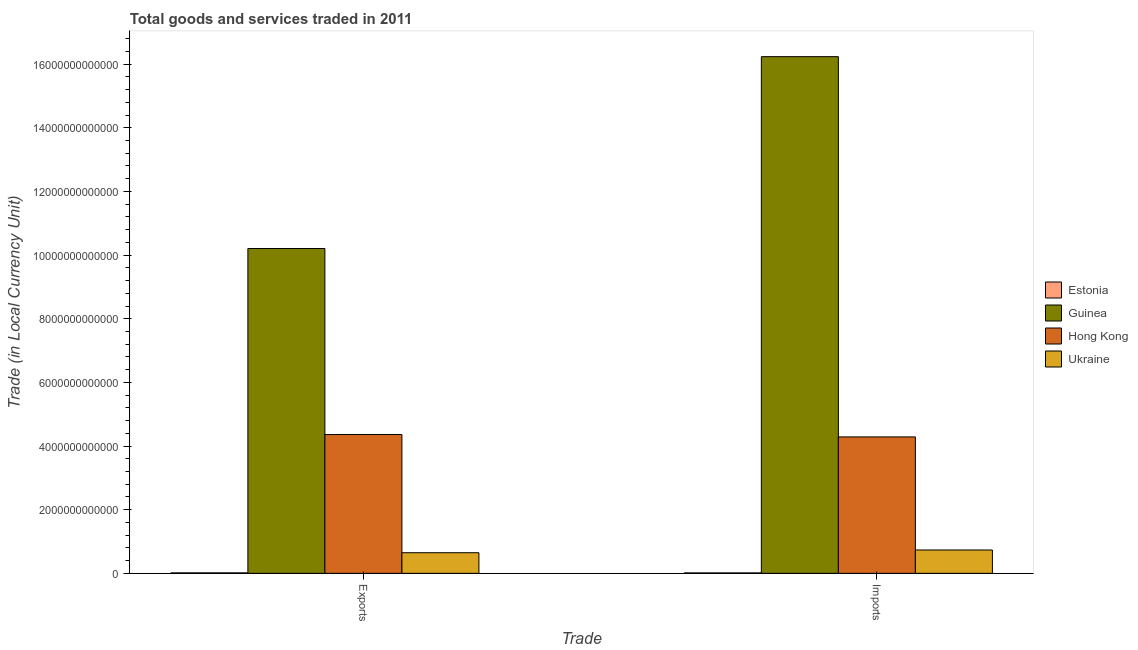Are the number of bars per tick equal to the number of legend labels?
Your answer should be very brief. Yes. Are the number of bars on each tick of the X-axis equal?
Offer a very short reply. Yes. How many bars are there on the 1st tick from the left?
Your response must be concise. 4. How many bars are there on the 1st tick from the right?
Offer a terse response. 4. What is the label of the 2nd group of bars from the left?
Keep it short and to the point. Imports. What is the imports of goods and services in Estonia?
Ensure brevity in your answer.  1.35e+1. Across all countries, what is the maximum imports of goods and services?
Ensure brevity in your answer.  1.62e+13. Across all countries, what is the minimum export of goods and services?
Provide a short and direct response. 1.44e+1. In which country was the export of goods and services maximum?
Your response must be concise. Guinea. In which country was the export of goods and services minimum?
Give a very brief answer. Estonia. What is the total imports of goods and services in the graph?
Make the answer very short. 2.13e+13. What is the difference between the imports of goods and services in Estonia and that in Ukraine?
Make the answer very short. -7.20e+11. What is the difference between the export of goods and services in Estonia and the imports of goods and services in Hong Kong?
Ensure brevity in your answer.  -4.27e+12. What is the average imports of goods and services per country?
Give a very brief answer. 5.32e+12. What is the difference between the export of goods and services and imports of goods and services in Hong Kong?
Keep it short and to the point. 7.45e+1. What is the ratio of the export of goods and services in Guinea to that in Estonia?
Your response must be concise. 707.66. Is the export of goods and services in Guinea less than that in Estonia?
Ensure brevity in your answer.  No. What does the 1st bar from the left in Imports represents?
Make the answer very short. Estonia. What does the 4th bar from the right in Exports represents?
Ensure brevity in your answer.  Estonia. Are all the bars in the graph horizontal?
Your answer should be compact. No. What is the difference between two consecutive major ticks on the Y-axis?
Offer a terse response. 2.00e+12. Does the graph contain any zero values?
Your response must be concise. No. Does the graph contain grids?
Your answer should be very brief. No. Where does the legend appear in the graph?
Provide a succinct answer. Center right. How many legend labels are there?
Make the answer very short. 4. What is the title of the graph?
Provide a short and direct response. Total goods and services traded in 2011. Does "Yemen, Rep." appear as one of the legend labels in the graph?
Your answer should be very brief. No. What is the label or title of the X-axis?
Give a very brief answer. Trade. What is the label or title of the Y-axis?
Your response must be concise. Trade (in Local Currency Unit). What is the Trade (in Local Currency Unit) in Estonia in Exports?
Keep it short and to the point. 1.44e+1. What is the Trade (in Local Currency Unit) in Guinea in Exports?
Make the answer very short. 1.02e+13. What is the Trade (in Local Currency Unit) of Hong Kong in Exports?
Your answer should be compact. 4.36e+12. What is the Trade (in Local Currency Unit) of Ukraine in Exports?
Provide a succinct answer. 6.48e+11. What is the Trade (in Local Currency Unit) of Estonia in Imports?
Make the answer very short. 1.35e+1. What is the Trade (in Local Currency Unit) in Guinea in Imports?
Offer a very short reply. 1.62e+13. What is the Trade (in Local Currency Unit) in Hong Kong in Imports?
Make the answer very short. 4.29e+12. What is the Trade (in Local Currency Unit) in Ukraine in Imports?
Provide a short and direct response. 7.34e+11. Across all Trade, what is the maximum Trade (in Local Currency Unit) in Estonia?
Offer a very short reply. 1.44e+1. Across all Trade, what is the maximum Trade (in Local Currency Unit) of Guinea?
Provide a short and direct response. 1.62e+13. Across all Trade, what is the maximum Trade (in Local Currency Unit) of Hong Kong?
Your answer should be compact. 4.36e+12. Across all Trade, what is the maximum Trade (in Local Currency Unit) of Ukraine?
Provide a short and direct response. 7.34e+11. Across all Trade, what is the minimum Trade (in Local Currency Unit) of Estonia?
Keep it short and to the point. 1.35e+1. Across all Trade, what is the minimum Trade (in Local Currency Unit) in Guinea?
Offer a very short reply. 1.02e+13. Across all Trade, what is the minimum Trade (in Local Currency Unit) of Hong Kong?
Provide a short and direct response. 4.29e+12. Across all Trade, what is the minimum Trade (in Local Currency Unit) of Ukraine?
Your answer should be very brief. 6.48e+11. What is the total Trade (in Local Currency Unit) in Estonia in the graph?
Keep it short and to the point. 2.79e+1. What is the total Trade (in Local Currency Unit) in Guinea in the graph?
Your answer should be compact. 2.64e+13. What is the total Trade (in Local Currency Unit) in Hong Kong in the graph?
Your response must be concise. 8.65e+12. What is the total Trade (in Local Currency Unit) in Ukraine in the graph?
Offer a terse response. 1.38e+12. What is the difference between the Trade (in Local Currency Unit) in Estonia in Exports and that in Imports?
Ensure brevity in your answer.  9.55e+08. What is the difference between the Trade (in Local Currency Unit) in Guinea in Exports and that in Imports?
Make the answer very short. -6.03e+12. What is the difference between the Trade (in Local Currency Unit) in Hong Kong in Exports and that in Imports?
Offer a terse response. 7.45e+1. What is the difference between the Trade (in Local Currency Unit) of Ukraine in Exports and that in Imports?
Offer a very short reply. -8.59e+1. What is the difference between the Trade (in Local Currency Unit) in Estonia in Exports and the Trade (in Local Currency Unit) in Guinea in Imports?
Offer a terse response. -1.62e+13. What is the difference between the Trade (in Local Currency Unit) in Estonia in Exports and the Trade (in Local Currency Unit) in Hong Kong in Imports?
Your response must be concise. -4.27e+12. What is the difference between the Trade (in Local Currency Unit) in Estonia in Exports and the Trade (in Local Currency Unit) in Ukraine in Imports?
Provide a succinct answer. -7.19e+11. What is the difference between the Trade (in Local Currency Unit) of Guinea in Exports and the Trade (in Local Currency Unit) of Hong Kong in Imports?
Your answer should be compact. 5.92e+12. What is the difference between the Trade (in Local Currency Unit) of Guinea in Exports and the Trade (in Local Currency Unit) of Ukraine in Imports?
Your answer should be compact. 9.47e+12. What is the difference between the Trade (in Local Currency Unit) of Hong Kong in Exports and the Trade (in Local Currency Unit) of Ukraine in Imports?
Offer a very short reply. 3.63e+12. What is the average Trade (in Local Currency Unit) of Estonia per Trade?
Keep it short and to the point. 1.39e+1. What is the average Trade (in Local Currency Unit) in Guinea per Trade?
Make the answer very short. 1.32e+13. What is the average Trade (in Local Currency Unit) in Hong Kong per Trade?
Ensure brevity in your answer.  4.32e+12. What is the average Trade (in Local Currency Unit) of Ukraine per Trade?
Provide a succinct answer. 6.91e+11. What is the difference between the Trade (in Local Currency Unit) of Estonia and Trade (in Local Currency Unit) of Guinea in Exports?
Give a very brief answer. -1.02e+13. What is the difference between the Trade (in Local Currency Unit) of Estonia and Trade (in Local Currency Unit) of Hong Kong in Exports?
Offer a very short reply. -4.35e+12. What is the difference between the Trade (in Local Currency Unit) of Estonia and Trade (in Local Currency Unit) of Ukraine in Exports?
Offer a very short reply. -6.33e+11. What is the difference between the Trade (in Local Currency Unit) in Guinea and Trade (in Local Currency Unit) in Hong Kong in Exports?
Your answer should be very brief. 5.85e+12. What is the difference between the Trade (in Local Currency Unit) in Guinea and Trade (in Local Currency Unit) in Ukraine in Exports?
Ensure brevity in your answer.  9.56e+12. What is the difference between the Trade (in Local Currency Unit) in Hong Kong and Trade (in Local Currency Unit) in Ukraine in Exports?
Your answer should be very brief. 3.71e+12. What is the difference between the Trade (in Local Currency Unit) in Estonia and Trade (in Local Currency Unit) in Guinea in Imports?
Keep it short and to the point. -1.62e+13. What is the difference between the Trade (in Local Currency Unit) of Estonia and Trade (in Local Currency Unit) of Hong Kong in Imports?
Make the answer very short. -4.27e+12. What is the difference between the Trade (in Local Currency Unit) of Estonia and Trade (in Local Currency Unit) of Ukraine in Imports?
Offer a very short reply. -7.20e+11. What is the difference between the Trade (in Local Currency Unit) in Guinea and Trade (in Local Currency Unit) in Hong Kong in Imports?
Provide a succinct answer. 1.19e+13. What is the difference between the Trade (in Local Currency Unit) in Guinea and Trade (in Local Currency Unit) in Ukraine in Imports?
Ensure brevity in your answer.  1.55e+13. What is the difference between the Trade (in Local Currency Unit) in Hong Kong and Trade (in Local Currency Unit) in Ukraine in Imports?
Ensure brevity in your answer.  3.55e+12. What is the ratio of the Trade (in Local Currency Unit) of Estonia in Exports to that in Imports?
Ensure brevity in your answer.  1.07. What is the ratio of the Trade (in Local Currency Unit) in Guinea in Exports to that in Imports?
Your answer should be very brief. 0.63. What is the ratio of the Trade (in Local Currency Unit) of Hong Kong in Exports to that in Imports?
Make the answer very short. 1.02. What is the ratio of the Trade (in Local Currency Unit) in Ukraine in Exports to that in Imports?
Ensure brevity in your answer.  0.88. What is the difference between the highest and the second highest Trade (in Local Currency Unit) of Estonia?
Give a very brief answer. 9.55e+08. What is the difference between the highest and the second highest Trade (in Local Currency Unit) in Guinea?
Offer a terse response. 6.03e+12. What is the difference between the highest and the second highest Trade (in Local Currency Unit) of Hong Kong?
Your answer should be very brief. 7.45e+1. What is the difference between the highest and the second highest Trade (in Local Currency Unit) of Ukraine?
Ensure brevity in your answer.  8.59e+1. What is the difference between the highest and the lowest Trade (in Local Currency Unit) of Estonia?
Your answer should be very brief. 9.55e+08. What is the difference between the highest and the lowest Trade (in Local Currency Unit) in Guinea?
Keep it short and to the point. 6.03e+12. What is the difference between the highest and the lowest Trade (in Local Currency Unit) in Hong Kong?
Ensure brevity in your answer.  7.45e+1. What is the difference between the highest and the lowest Trade (in Local Currency Unit) in Ukraine?
Your response must be concise. 8.59e+1. 